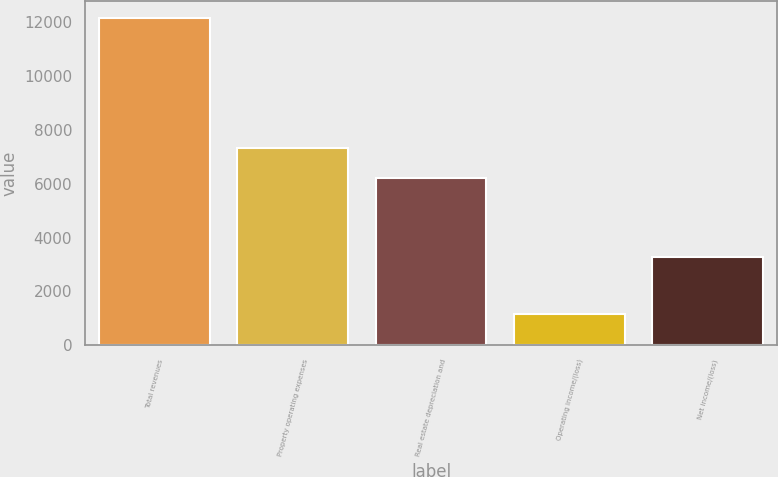Convert chart. <chart><loc_0><loc_0><loc_500><loc_500><bar_chart><fcel>Total revenues<fcel>Property operating expenses<fcel>Real estate depreciation and<fcel>Operating income/(loss)<fcel>Net income/(loss)<nl><fcel>12174<fcel>7319.3<fcel>6218<fcel>1161<fcel>3265<nl></chart> 